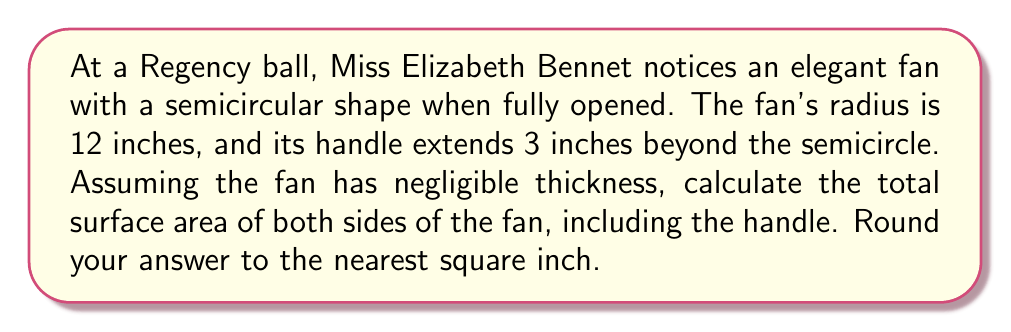Help me with this question. Let's approach this problem step-by-step, channeling the precision Mr. Darcy would appreciate:

1) The fan consists of two main parts: the semicircular portion and the rectangular handle.

2) For the semicircular portion:
   - The area of a semicircle is given by the formula: $A = \frac{1}{2} \pi r^2$
   - With a radius of 12 inches: $A = \frac{1}{2} \pi (12)^2 = 72\pi$ square inches

3) For the rectangular handle:
   - The length of the handle extending beyond the semicircle is 3 inches
   - The width of the handle is equal to the diameter of the semicircle: $2r = 2(12) = 24$ inches
   - Area of the handle: $A = 3 \times 24 = 72$ square inches

4) Total area of one side: $72\pi + 72$ square inches

5) Since we need to consider both sides of the fan:
   Total surface area $= 2(72\pi + 72) = 144\pi + 144$ square inches

6) Calculating and rounding to the nearest square inch:
   $144\pi + 144 \approx 596.37$ square inches
   Rounded to the nearest square inch: 596 square inches

[asy]
import geometry;

size(200);
pair O = (0,0);
real r = 4;
path semicircle = arc(O, r, 0, 180);
draw(semicircle);
draw((r,0)--(r,-1)--(0,-1)--(0,0));
draw((-r,0)--(r,0),dashed);
label("12\"", (0,0), S);
label("3\"", (r,-0.5), E);
[/asy]
Answer: The total surface area of both sides of the fan, including the handle, is approximately 596 square inches. 